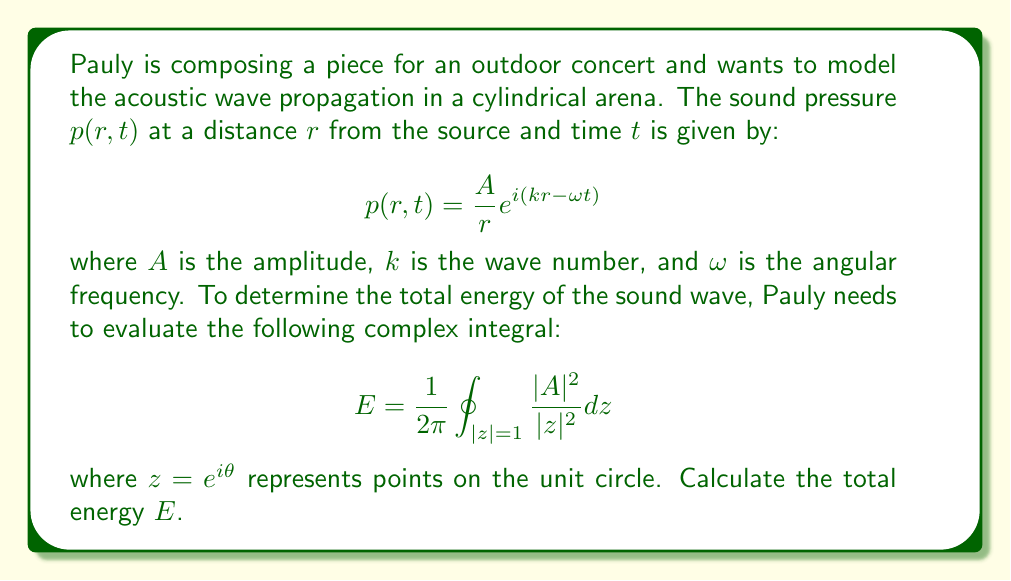Teach me how to tackle this problem. Let's approach this step-by-step:

1) First, we need to understand what the integral represents. It's a contour integral around the unit circle in the complex plane.

2) We can parameterize the unit circle using $z = e^{i\theta}$, where $\theta$ goes from 0 to $2\pi$.

3) With this parameterization, $dz = ie^{i\theta}d\theta$, and $|z|^2 = 1$.

4) Substituting these into our integral:

   $$E = \frac{1}{2\pi} \int_0^{2\pi} \frac{|A|^2}{|e^{i\theta}|^2} ie^{i\theta}d\theta$$

5) Simplify:
   
   $$E = \frac{1}{2\pi} \int_0^{2\pi} |A|^2 ie^{i\theta}d\theta$$

6) $|A|^2$ is a constant, so we can take it out of the integral:

   $$E = \frac{|A|^2}{2\pi} i \int_0^{2\pi} e^{i\theta}d\theta$$

7) This integral is a well-known result. The integral of $e^{i\theta}$ from 0 to $2\pi$ is zero:

   $$\int_0^{2\pi} e^{i\theta}d\theta = 0$$

8) Therefore, our final result is:

   $$E = \frac{|A|^2}{2\pi} i \cdot 0 = 0$$

This result shows that the total energy over a complete cycle of the wave is zero, which is consistent with the nature of propagating waves where energy oscillates between potential and kinetic forms.
Answer: $E = 0$ 